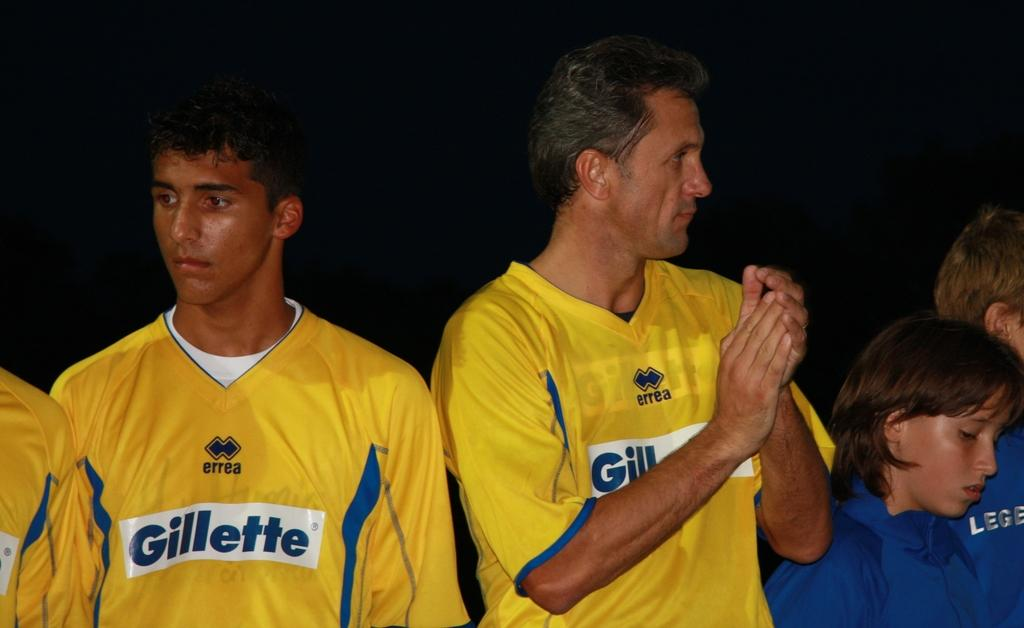<image>
Give a short and clear explanation of the subsequent image. Some people wearing yellow shirts which read Gillette. 